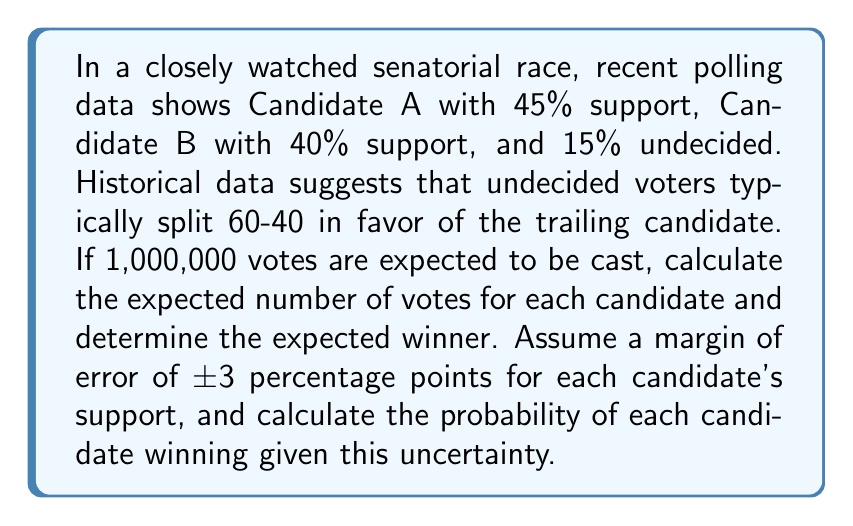Give your solution to this math problem. Let's approach this step-by-step:

1) First, let's calculate the expected vote distribution:
   Candidate A: 45% + (15% × 0.4) = 51%
   Candidate B: 40% + (15% × 0.6) = 49%

2) Expected votes:
   Candidate A: $1,000,000 \times 0.51 = 510,000$
   Candidate B: $1,000,000 \times 0.49 = 490,000$

3) To calculate the probability of winning, we need to consider the margin of error. We'll use a normal distribution to model this uncertainty.

4) The standard deviation (σ) can be calculated from the margin of error:
   $\text{Margin of Error} = 1.96 \times \sigma$
   $3 = 1.96 \times \sigma$
   $\sigma = \frac{3}{1.96} \approx 1.53$

5) The difference in support is 2 percentage points (51% - 49%). We need to find the probability that this difference is greater than 0, given the uncertainty.

6) The standard error of the difference is:
   $SE = \sqrt{1.53^2 + 1.53^2} \approx 2.16$

7) The z-score is:
   $z = \frac{2}{2.16} \approx 0.93$

8) The probability of Candidate A winning is:
   $P(A \text{ wins}) = 1 - \Phi(-0.93) \approx 0.8238$

   Where $\Phi$ is the cumulative distribution function of the standard normal distribution.

9) The probability of Candidate B winning is:
   $P(B \text{ wins}) = 1 - 0.8238 = 0.1762$
Answer: Expected votes: A: 510,000, B: 490,000. Probability of winning: A: 82.38%, B: 17.62%. 